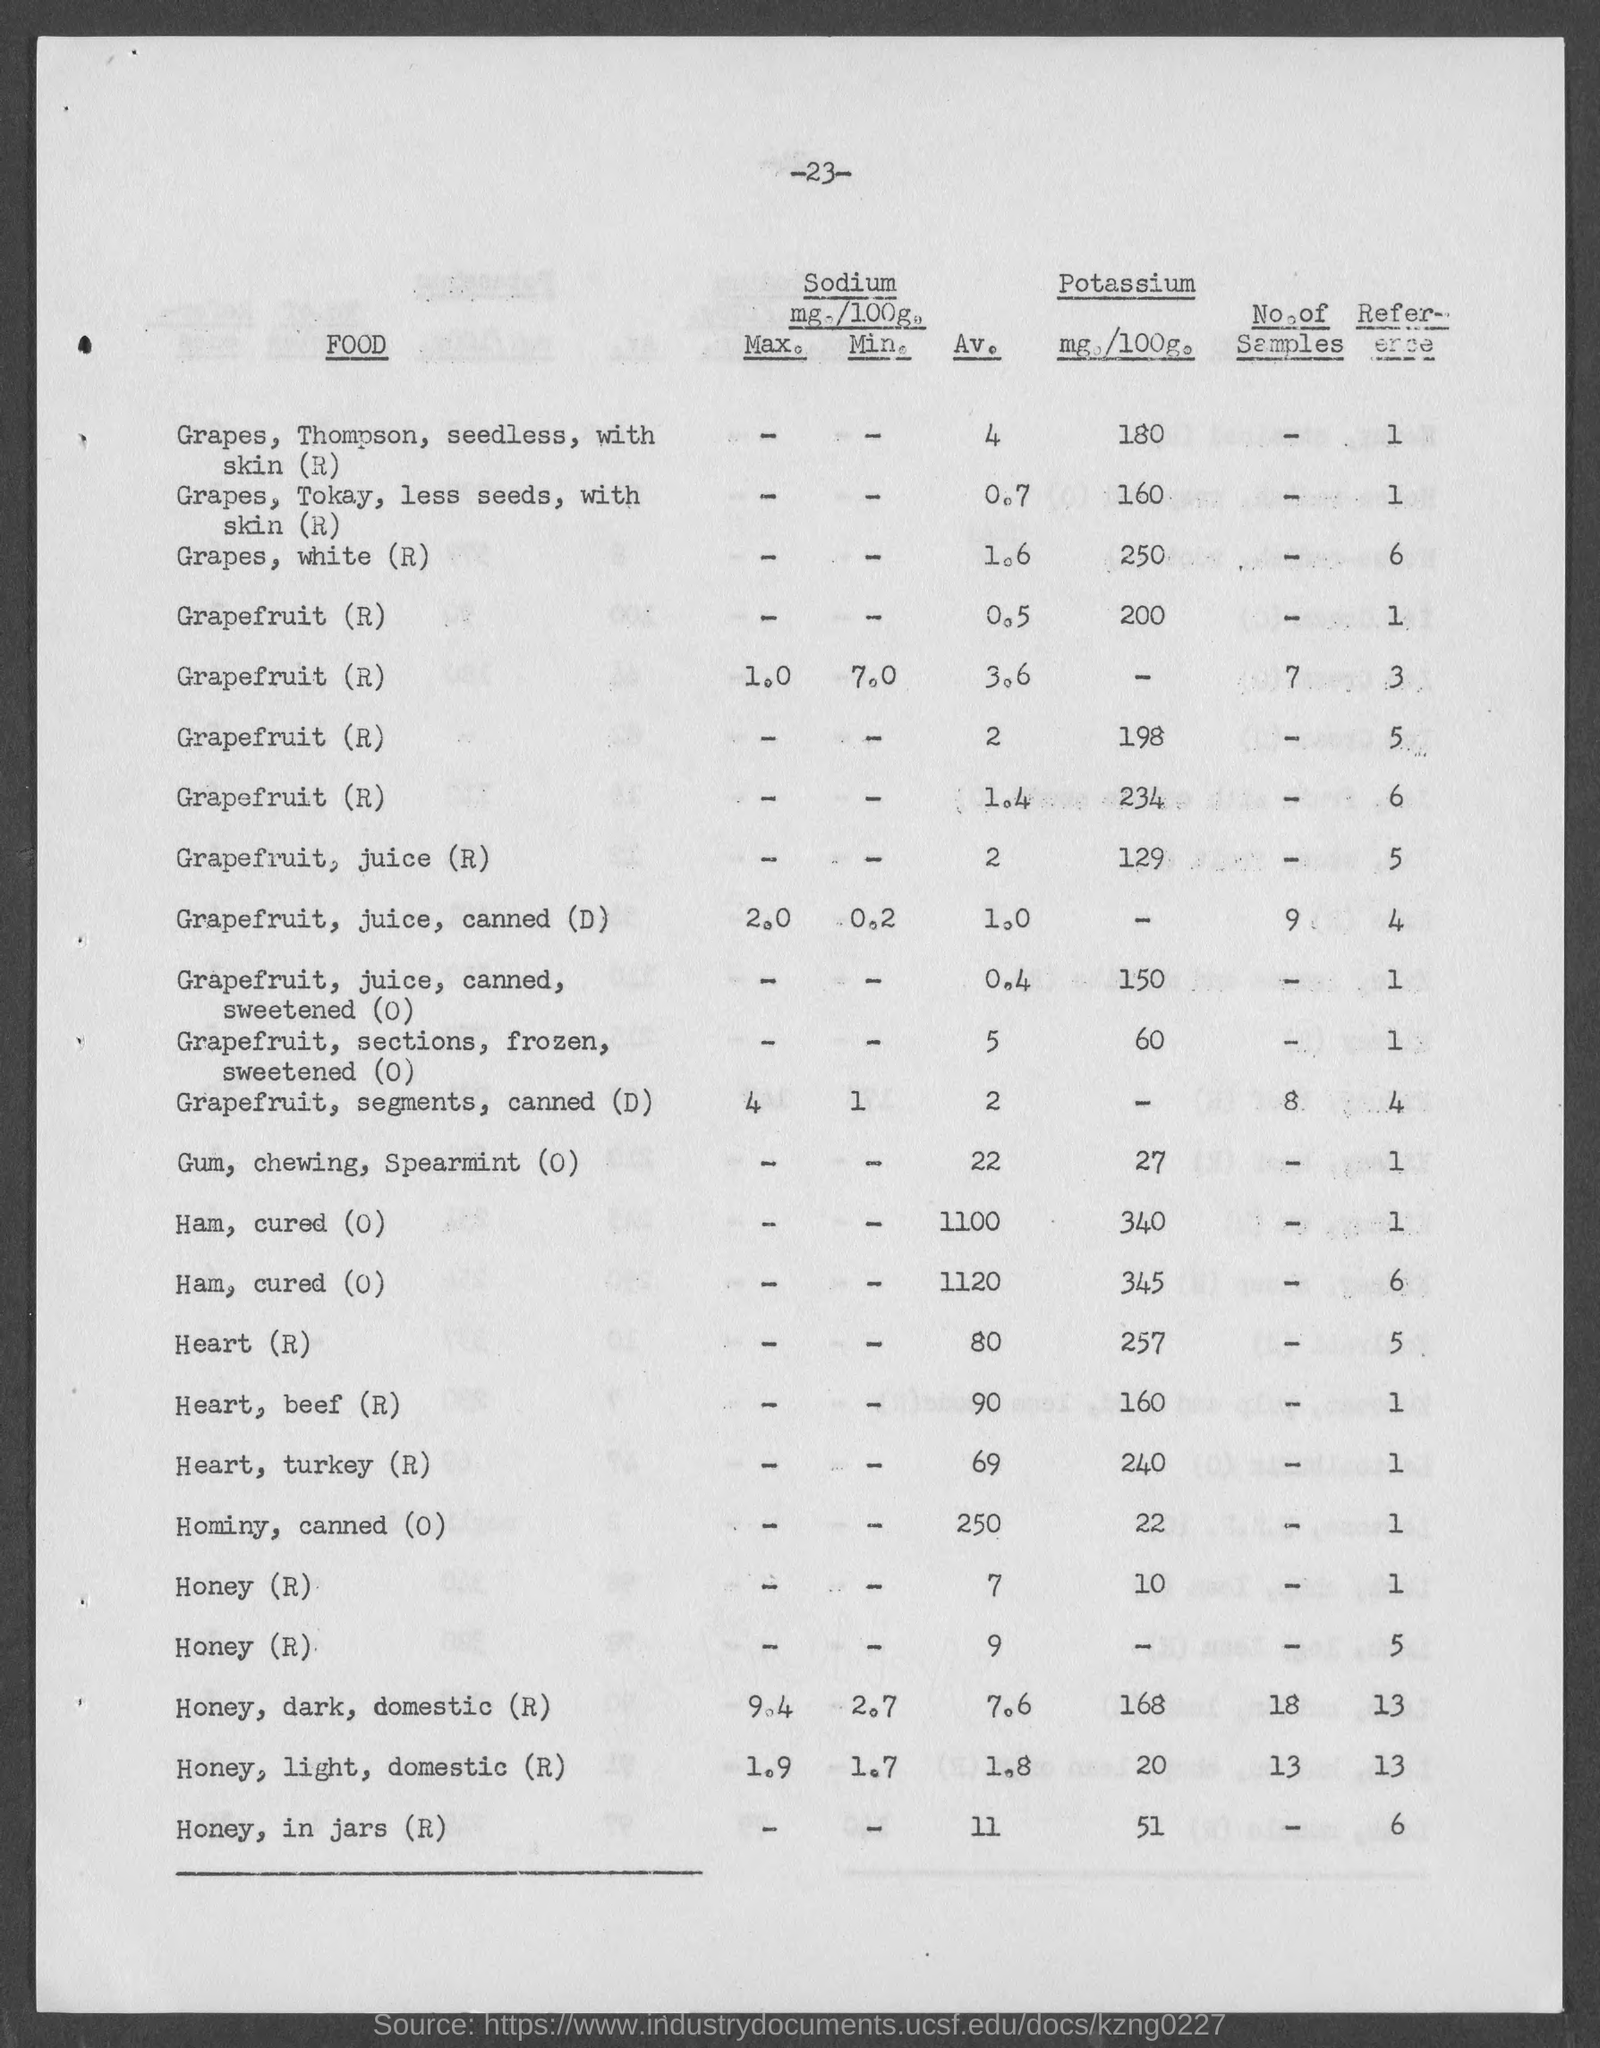What is the Av. sodium in Grapes, white (R)?
Give a very brief answer. 1.6. What is the Av. sodium in Grapefruit, juice (R)?
Offer a terse response. 2. What is the Av. sodium in Grapefruit, juice, canned (D)?
Offer a terse response. 1.0. What is the Av. sodium in Gum, chewing, Spearmint (0)?
Offer a terse response. 22. What is the potassium in Gum, chewing, Spearmint (0)?
Keep it short and to the point. 27. What is the Av. sodium in Heart(R)?
Your answer should be very brief. 80. What is the Potassium in Heart(R)?
Your answer should be very brief. 257. What is the Av. sodium in Heart, beef (R)?
Your response must be concise. 90. What is the Potassium in Heart, beef (R)?
Give a very brief answer. 160. What is the Av. sodium in Heart, turkey (R)?
Your answer should be very brief. 69. 